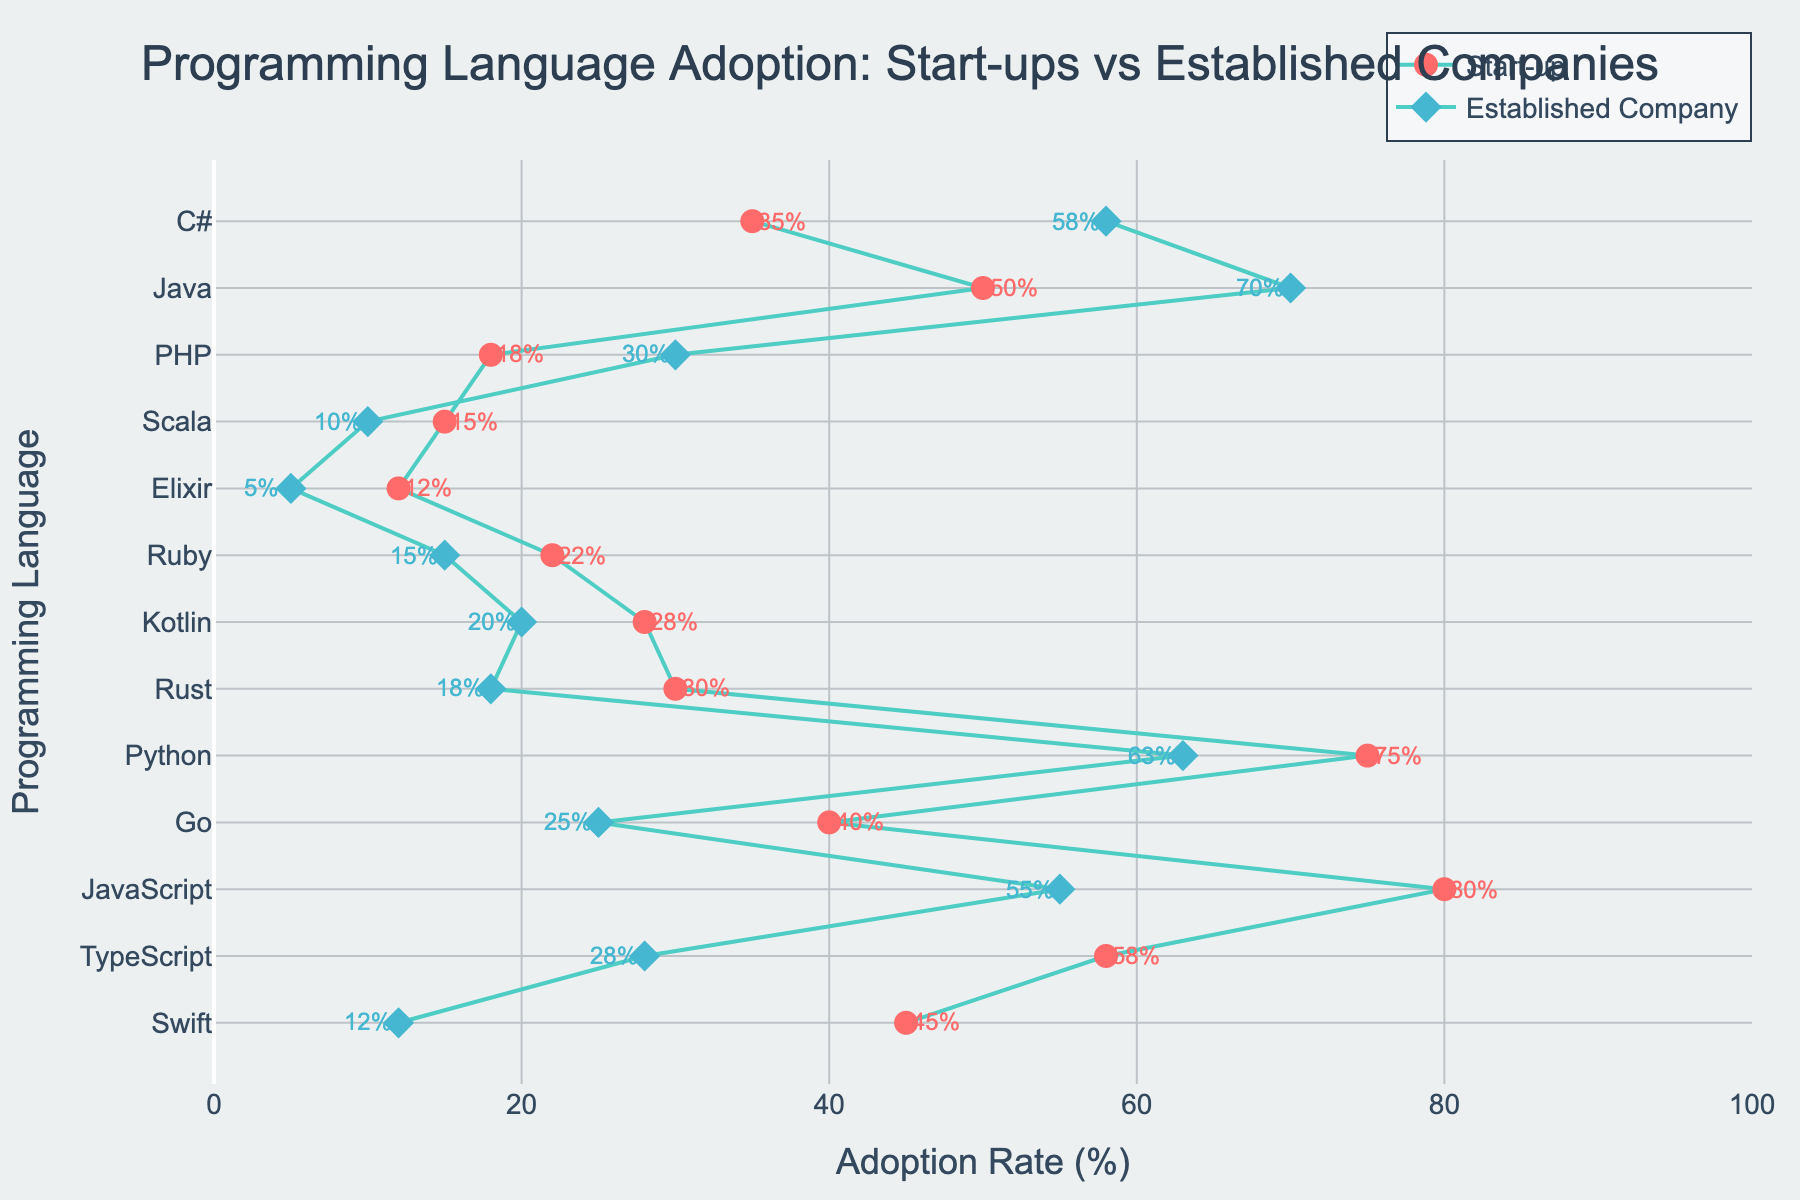What's the title of the plot? The title is typically displayed at the top of the plot, centered, and usually in larger font compared to other text elements. The title helps summarize what the plot represents. In this case, it helps the viewer understand the context and main idea of the visual data presented.
Answer: Programming Language Adoption: Start-ups vs Established Companies How many different programming languages are displayed in the plot? Count the unique programming languages listed on the y-axis. Each one corresponds to a different dumbbell in the plot.
Answer: 13 Which programming language has the highest adoption rate among start-ups? Look at the left markers (representing start-up adoption rates) and identify the highest value. Check which programming language corresponds to that value on the y-axis.
Answer: JavaScript What is the difference in adoption rates for Python between start-ups and established companies? Find Python on the y-axis, then find the two markers corresponding to Python. Subtract the adoption rate of established companies from that of start-ups.
Answer: 12% Which company type, start-ups or established companies, uses Java more? Locate Java on the y-axis, then compare the two markers for Java to see which one is higher.
Answer: Established companies For which programming language is the difference in adoption rate the largest? Examine the lengths of all the lines connecting pairs of markers. The largest difference will correspond to the longest line.
Answer: Python Is Swift more popular among start-ups or established companies? Find Swift on the y-axis and compare the two markers next to it. The one with the higher value indicates which company type uses it more.
Answer: Start-ups Which programming language has a closer adoption rate between start-ups and established companies? Identify the lines between markers that are shortest, indicating that the difference in adoption rates is minimal. This shows similar adoption rates.
Answer: Scala What is the average adoption rate of TypeScript for both start-ups and established companies combined? Find the adoption rates of TypeScript for both start-ups and established companies, sum them up, and divide by 2.
Answer: 43% How many programming languages have an adoption rate above 50% among start-ups? Count the number of markers on the left side (start-up adoption rates) that are above the value of 50%.
Answer: 4 